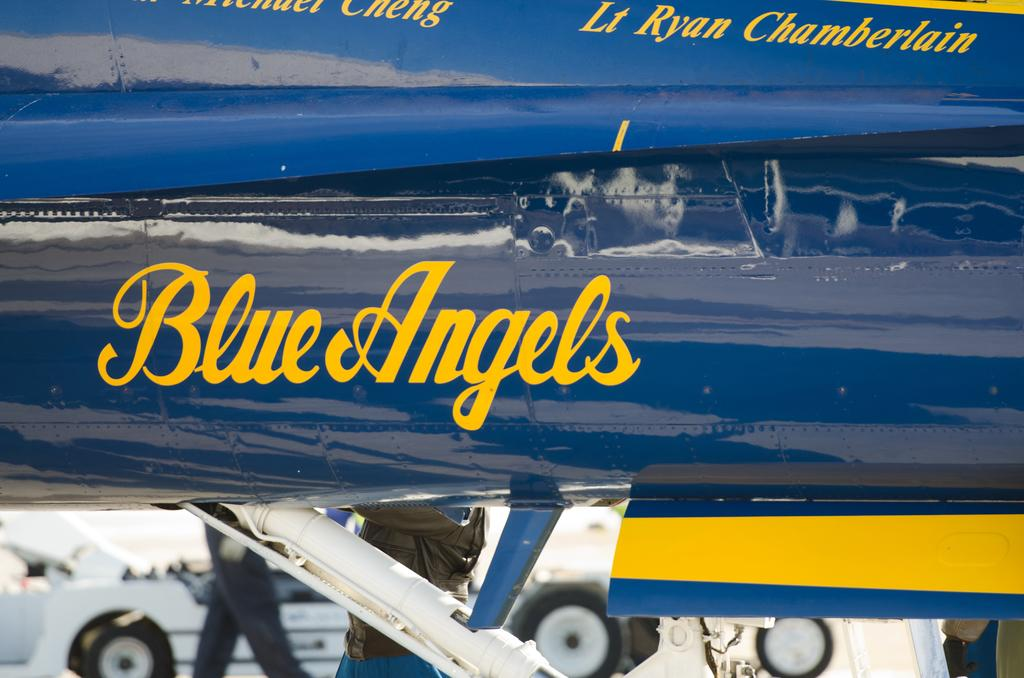<image>
Share a concise interpretation of the image provided. a close up of a Blue Angels sign on an airplane 